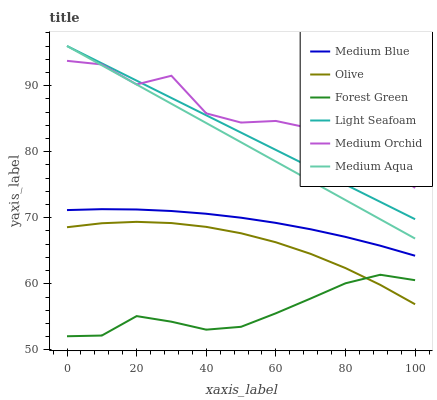Does Forest Green have the minimum area under the curve?
Answer yes or no. Yes. Does Medium Orchid have the maximum area under the curve?
Answer yes or no. Yes. Does Medium Blue have the minimum area under the curve?
Answer yes or no. No. Does Medium Blue have the maximum area under the curve?
Answer yes or no. No. Is Medium Aqua the smoothest?
Answer yes or no. Yes. Is Medium Orchid the roughest?
Answer yes or no. Yes. Is Medium Blue the smoothest?
Answer yes or no. No. Is Medium Blue the roughest?
Answer yes or no. No. Does Medium Blue have the lowest value?
Answer yes or no. No. Does Medium Blue have the highest value?
Answer yes or no. No. Is Olive less than Light Seafoam?
Answer yes or no. Yes. Is Medium Aqua greater than Forest Green?
Answer yes or no. Yes. Does Olive intersect Light Seafoam?
Answer yes or no. No. 